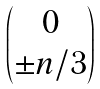Convert formula to latex. <formula><loc_0><loc_0><loc_500><loc_500>\begin{pmatrix} 0 \\ \pm n / 3 \end{pmatrix}</formula> 